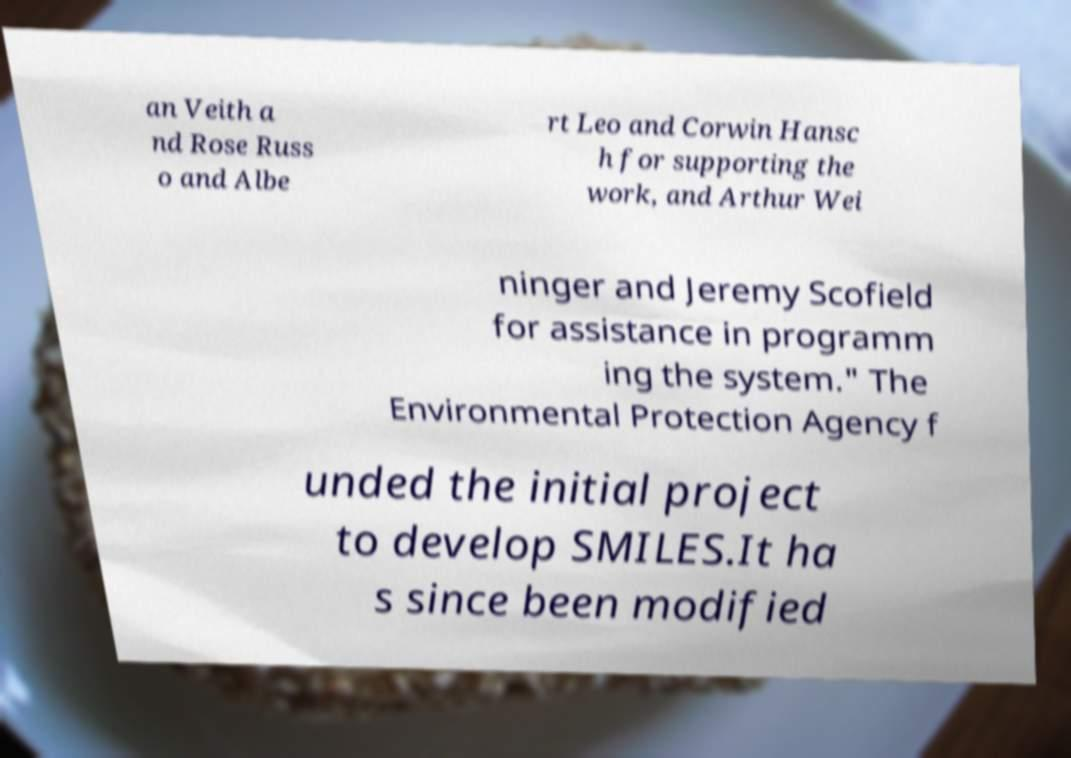Please identify and transcribe the text found in this image. an Veith a nd Rose Russ o and Albe rt Leo and Corwin Hansc h for supporting the work, and Arthur Wei ninger and Jeremy Scofield for assistance in programm ing the system." The Environmental Protection Agency f unded the initial project to develop SMILES.It ha s since been modified 